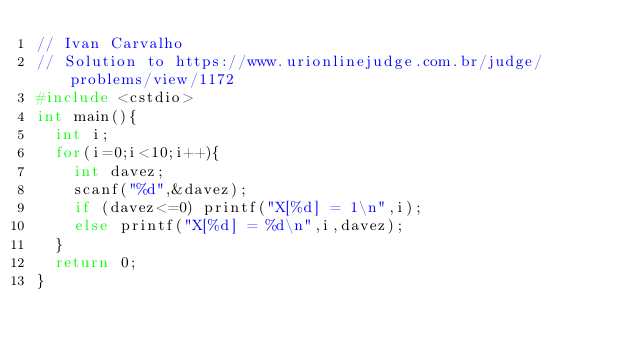Convert code to text. <code><loc_0><loc_0><loc_500><loc_500><_C++_>// Ivan Carvalho
// Solution to https://www.urionlinejudge.com.br/judge/problems/view/1172
#include <cstdio>
int main(){
	int i;
	for(i=0;i<10;i++){
		int davez;
		scanf("%d",&davez);
		if (davez<=0) printf("X[%d] = 1\n",i);
		else printf("X[%d] = %d\n",i,davez);
	}
	return 0;
}
</code> 